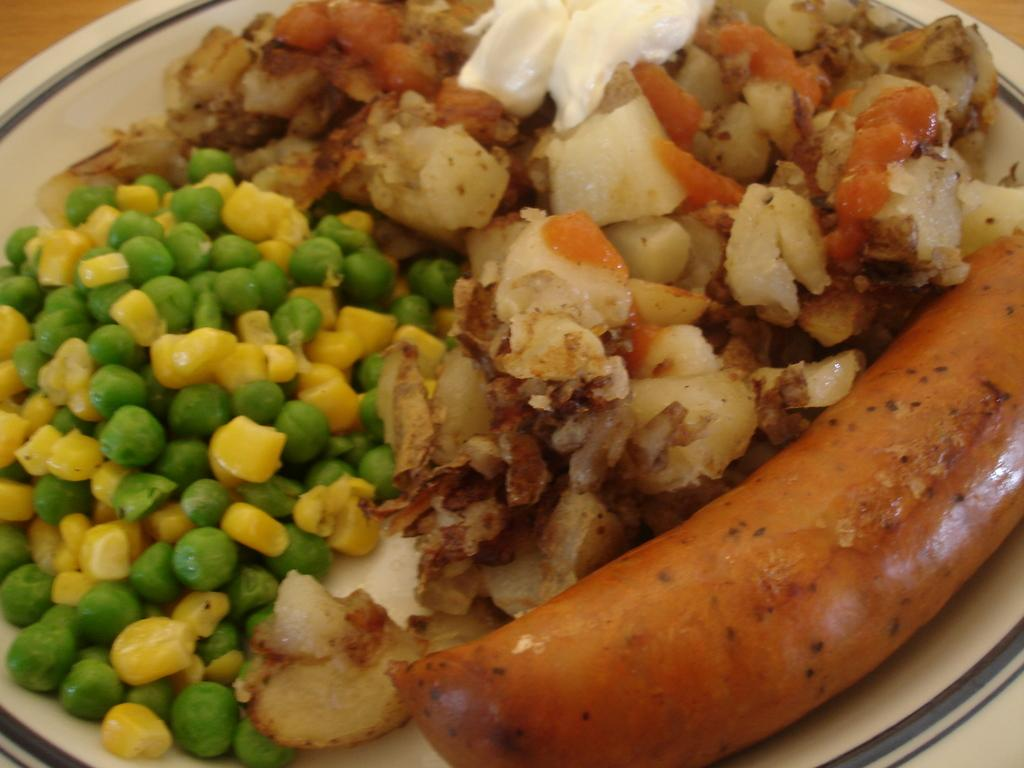What is present on the plate in the image? There are food items on a plate in the image. Are there any ants crawling on the food items in the image? There is no indication of ants in the image; it only shows food items on a plate. 